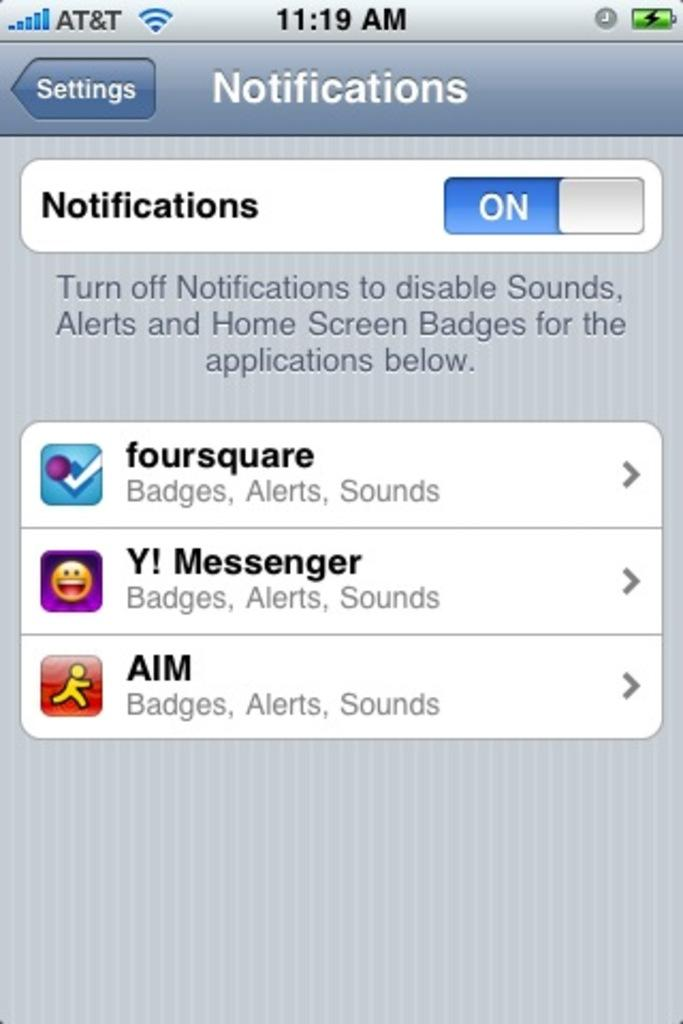Provide a one-sentence caption for the provided image. An old screen shot of an iPhone screen showing notifications for AIM, and foursquare. 